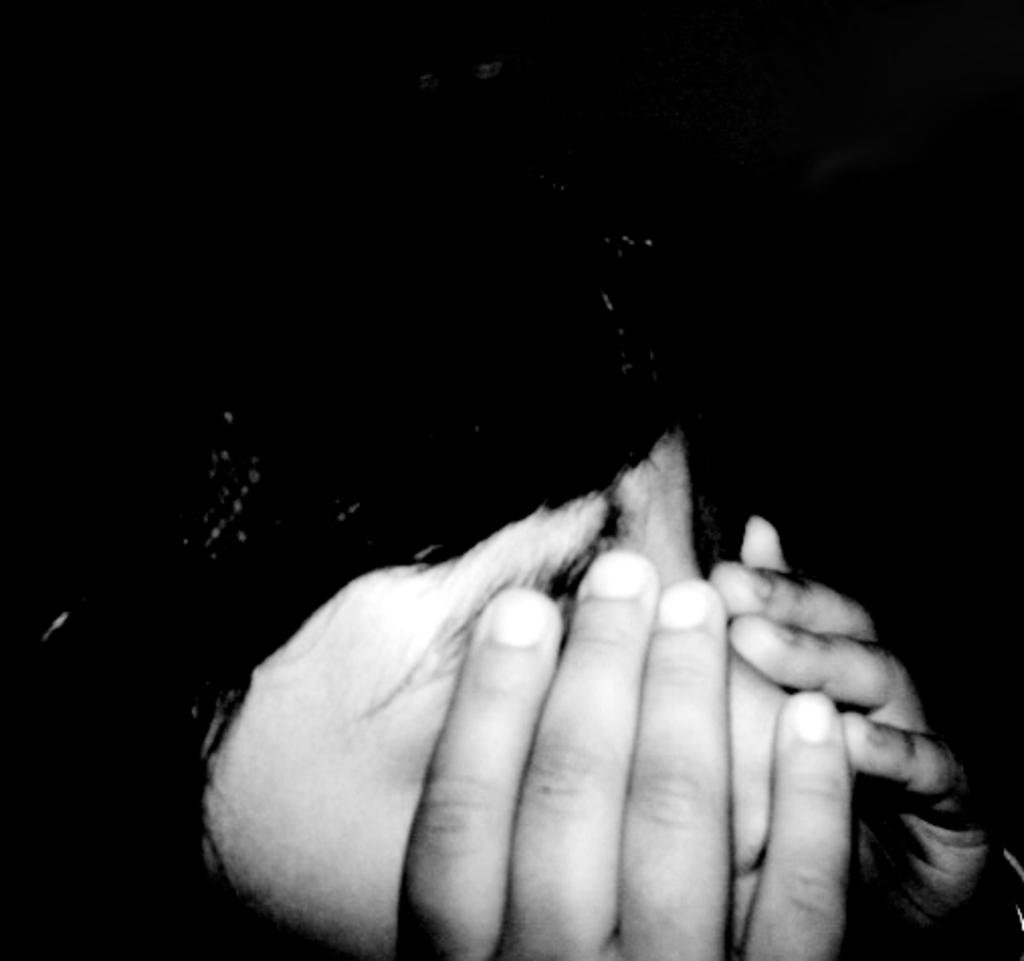What can be seen in the image? There are hands visible in the image. What is the background of the image look like? The background of the image is blurred. What is the color scheme of the image? The image is black and white in color. What type of sweater is the person wearing in the image? There is no person or sweater visible in the image; only hands are present. 